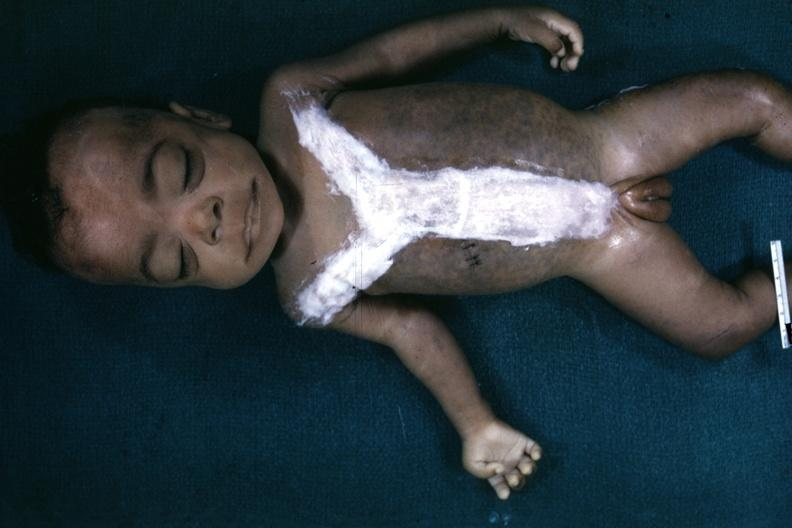what is very good representation of mongoloid facies and one hand opened quite good example?
Answer the question using a single word or phrase. Very 